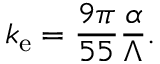<formula> <loc_0><loc_0><loc_500><loc_500>k _ { e } = \frac { 9 \pi } { 5 5 } \frac { \alpha } { \Lambda } .</formula> 